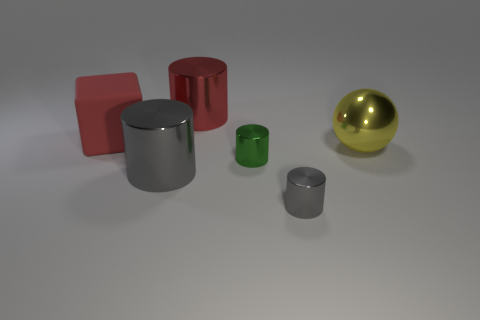Is the color of the large cylinder that is left of the big red shiny thing the same as the big matte block? no 